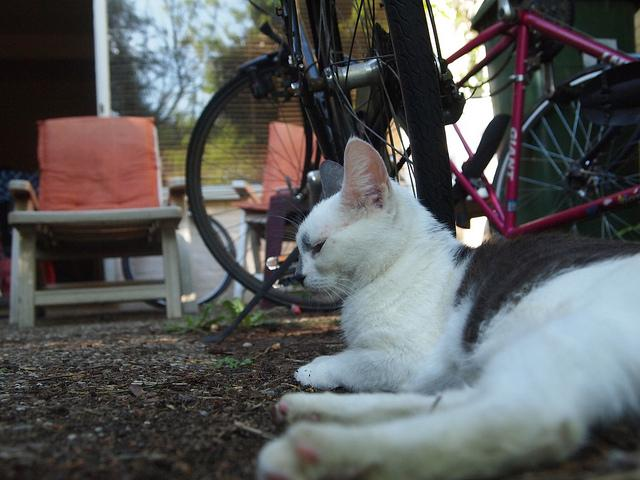What faces the most danger of getting hurt if people go to ride the bikes?

Choices:
A) cat
B) people
C) chair
D) bikes cat 